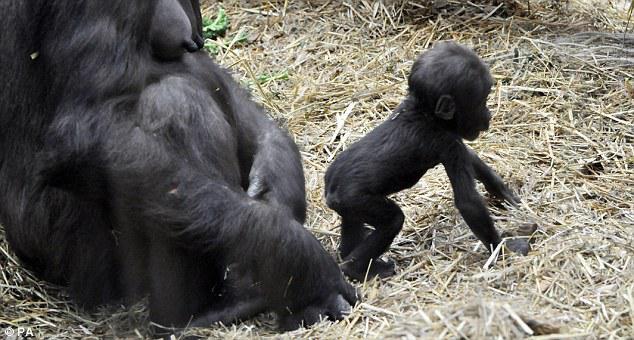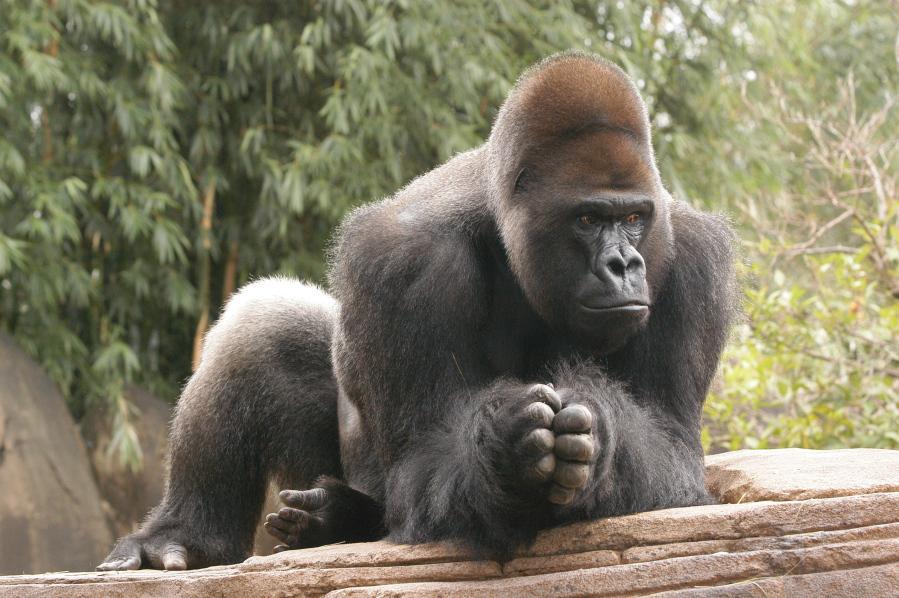The first image is the image on the left, the second image is the image on the right. Examine the images to the left and right. Is the description "One of the images shows exactly one adult gorilla and one baby gorilla in close proximity." accurate? Answer yes or no. Yes. The first image is the image on the left, the second image is the image on the right. Analyze the images presented: Is the assertion "An image shows a baby gorilla on the right and one adult gorilla, which is sitting on the left." valid? Answer yes or no. Yes. 